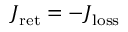Convert formula to latex. <formula><loc_0><loc_0><loc_500><loc_500>J _ { r e t } = - J _ { l o s s }</formula> 